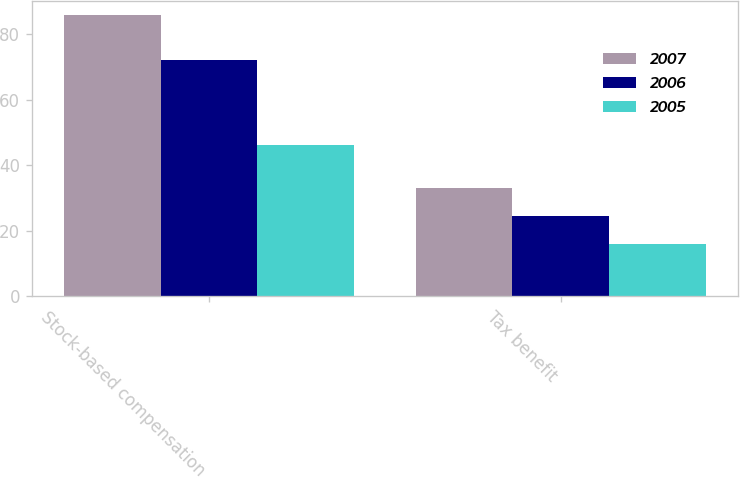Convert chart to OTSL. <chart><loc_0><loc_0><loc_500><loc_500><stacked_bar_chart><ecel><fcel>Stock-based compensation<fcel>Tax benefit<nl><fcel>2007<fcel>85.9<fcel>33.1<nl><fcel>2006<fcel>72.3<fcel>24.4<nl><fcel>2005<fcel>46.1<fcel>15.9<nl></chart> 